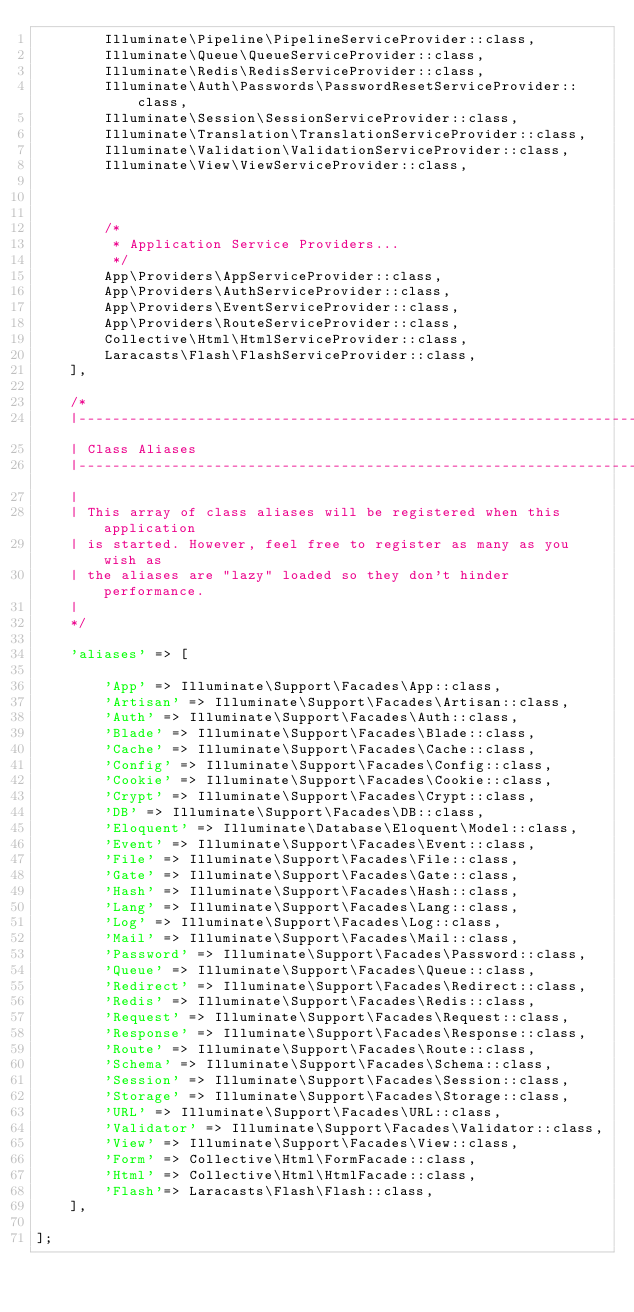<code> <loc_0><loc_0><loc_500><loc_500><_PHP_>        Illuminate\Pipeline\PipelineServiceProvider::class,
        Illuminate\Queue\QueueServiceProvider::class,
        Illuminate\Redis\RedisServiceProvider::class,
        Illuminate\Auth\Passwords\PasswordResetServiceProvider::class,
        Illuminate\Session\SessionServiceProvider::class,
        Illuminate\Translation\TranslationServiceProvider::class,
        Illuminate\Validation\ValidationServiceProvider::class,
        Illuminate\View\ViewServiceProvider::class,
        
        

        /*
         * Application Service Providers...
         */
        App\Providers\AppServiceProvider::class,
        App\Providers\AuthServiceProvider::class,
        App\Providers\EventServiceProvider::class,
        App\Providers\RouteServiceProvider::class,
        Collective\Html\HtmlServiceProvider::class,
        Laracasts\Flash\FlashServiceProvider::class,
    ],

    /*
    |--------------------------------------------------------------------------
    | Class Aliases
    |--------------------------------------------------------------------------
    |
    | This array of class aliases will be registered when this application
    | is started. However, feel free to register as many as you wish as
    | the aliases are "lazy" loaded so they don't hinder performance.
    |
    */

    'aliases' => [

        'App' => Illuminate\Support\Facades\App::class,
        'Artisan' => Illuminate\Support\Facades\Artisan::class,
        'Auth' => Illuminate\Support\Facades\Auth::class,
        'Blade' => Illuminate\Support\Facades\Blade::class,
        'Cache' => Illuminate\Support\Facades\Cache::class,
        'Config' => Illuminate\Support\Facades\Config::class,
        'Cookie' => Illuminate\Support\Facades\Cookie::class,
        'Crypt' => Illuminate\Support\Facades\Crypt::class,
        'DB' => Illuminate\Support\Facades\DB::class,
        'Eloquent' => Illuminate\Database\Eloquent\Model::class,
        'Event' => Illuminate\Support\Facades\Event::class,
        'File' => Illuminate\Support\Facades\File::class,
        'Gate' => Illuminate\Support\Facades\Gate::class,
        'Hash' => Illuminate\Support\Facades\Hash::class,
        'Lang' => Illuminate\Support\Facades\Lang::class,
        'Log' => Illuminate\Support\Facades\Log::class,
        'Mail' => Illuminate\Support\Facades\Mail::class,
        'Password' => Illuminate\Support\Facades\Password::class,
        'Queue' => Illuminate\Support\Facades\Queue::class,
        'Redirect' => Illuminate\Support\Facades\Redirect::class,
        'Redis' => Illuminate\Support\Facades\Redis::class,
        'Request' => Illuminate\Support\Facades\Request::class,
        'Response' => Illuminate\Support\Facades\Response::class,
        'Route' => Illuminate\Support\Facades\Route::class,
        'Schema' => Illuminate\Support\Facades\Schema::class,
        'Session' => Illuminate\Support\Facades\Session::class,
        'Storage' => Illuminate\Support\Facades\Storage::class,
        'URL' => Illuminate\Support\Facades\URL::class,
        'Validator' => Illuminate\Support\Facades\Validator::class,
        'View' => Illuminate\Support\Facades\View::class,
        'Form' => Collective\Html\FormFacade::class,
        'Html' => Collective\Html\HtmlFacade::class,
        'Flash'=> Laracasts\Flash\Flash::class,
    ],

];
</code> 